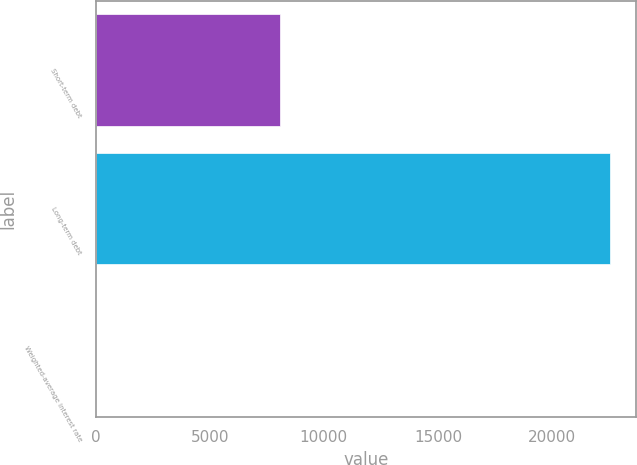<chart> <loc_0><loc_0><loc_500><loc_500><bar_chart><fcel>Short-term debt<fcel>Long-term debt<fcel>Weighted-average interest rate<nl><fcel>8083<fcel>22551<fcel>2.4<nl></chart> 